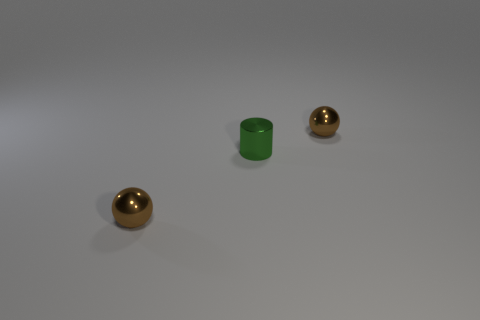How do the textures of the objects in the image compare? The objects in the image display a variety of textures: the small green cylinder appears to have a smooth, perhaps metallic surface, while the two spherical objects seem to have a reflective surface with a glossy finish, indicative of a polished metal or a similar material. 